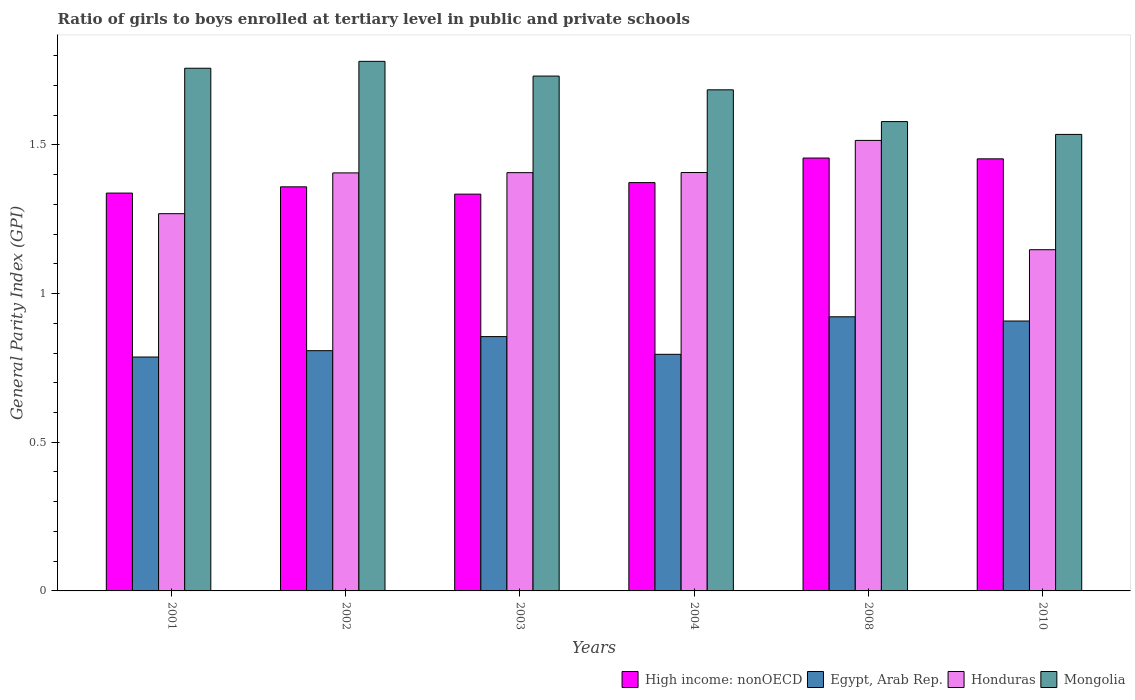How many bars are there on the 4th tick from the left?
Offer a very short reply. 4. What is the label of the 1st group of bars from the left?
Provide a short and direct response. 2001. In how many cases, is the number of bars for a given year not equal to the number of legend labels?
Make the answer very short. 0. What is the general parity index in Egypt, Arab Rep. in 2003?
Make the answer very short. 0.86. Across all years, what is the maximum general parity index in High income: nonOECD?
Offer a terse response. 1.46. Across all years, what is the minimum general parity index in Honduras?
Your response must be concise. 1.15. In which year was the general parity index in Honduras maximum?
Make the answer very short. 2008. What is the total general parity index in Mongolia in the graph?
Offer a very short reply. 10.07. What is the difference between the general parity index in Mongolia in 2001 and that in 2003?
Provide a succinct answer. 0.03. What is the difference between the general parity index in Egypt, Arab Rep. in 2002 and the general parity index in High income: nonOECD in 2004?
Offer a terse response. -0.57. What is the average general parity index in Egypt, Arab Rep. per year?
Your answer should be compact. 0.85. In the year 2008, what is the difference between the general parity index in High income: nonOECD and general parity index in Honduras?
Make the answer very short. -0.06. What is the ratio of the general parity index in Mongolia in 2002 to that in 2004?
Keep it short and to the point. 1.06. Is the general parity index in Egypt, Arab Rep. in 2002 less than that in 2003?
Ensure brevity in your answer.  Yes. What is the difference between the highest and the second highest general parity index in Mongolia?
Make the answer very short. 0.02. What is the difference between the highest and the lowest general parity index in High income: nonOECD?
Your response must be concise. 0.12. In how many years, is the general parity index in Mongolia greater than the average general parity index in Mongolia taken over all years?
Your answer should be very brief. 4. What does the 1st bar from the left in 2001 represents?
Your answer should be very brief. High income: nonOECD. What does the 3rd bar from the right in 2002 represents?
Your answer should be compact. Egypt, Arab Rep. What is the difference between two consecutive major ticks on the Y-axis?
Your answer should be compact. 0.5. Does the graph contain grids?
Your answer should be compact. No. Where does the legend appear in the graph?
Your answer should be very brief. Bottom right. How many legend labels are there?
Provide a succinct answer. 4. How are the legend labels stacked?
Your answer should be compact. Horizontal. What is the title of the graph?
Make the answer very short. Ratio of girls to boys enrolled at tertiary level in public and private schools. What is the label or title of the X-axis?
Ensure brevity in your answer.  Years. What is the label or title of the Y-axis?
Keep it short and to the point. General Parity Index (GPI). What is the General Parity Index (GPI) in High income: nonOECD in 2001?
Make the answer very short. 1.34. What is the General Parity Index (GPI) of Egypt, Arab Rep. in 2001?
Offer a very short reply. 0.79. What is the General Parity Index (GPI) in Honduras in 2001?
Offer a very short reply. 1.27. What is the General Parity Index (GPI) of Mongolia in 2001?
Make the answer very short. 1.76. What is the General Parity Index (GPI) in High income: nonOECD in 2002?
Offer a very short reply. 1.36. What is the General Parity Index (GPI) of Egypt, Arab Rep. in 2002?
Offer a very short reply. 0.81. What is the General Parity Index (GPI) in Honduras in 2002?
Your response must be concise. 1.41. What is the General Parity Index (GPI) of Mongolia in 2002?
Keep it short and to the point. 1.78. What is the General Parity Index (GPI) of High income: nonOECD in 2003?
Provide a short and direct response. 1.33. What is the General Parity Index (GPI) of Egypt, Arab Rep. in 2003?
Your answer should be compact. 0.86. What is the General Parity Index (GPI) of Honduras in 2003?
Offer a terse response. 1.41. What is the General Parity Index (GPI) in Mongolia in 2003?
Keep it short and to the point. 1.73. What is the General Parity Index (GPI) of High income: nonOECD in 2004?
Provide a succinct answer. 1.37. What is the General Parity Index (GPI) of Egypt, Arab Rep. in 2004?
Your answer should be very brief. 0.8. What is the General Parity Index (GPI) of Honduras in 2004?
Give a very brief answer. 1.41. What is the General Parity Index (GPI) in Mongolia in 2004?
Make the answer very short. 1.69. What is the General Parity Index (GPI) in High income: nonOECD in 2008?
Your answer should be compact. 1.46. What is the General Parity Index (GPI) of Egypt, Arab Rep. in 2008?
Your answer should be very brief. 0.92. What is the General Parity Index (GPI) of Honduras in 2008?
Your response must be concise. 1.51. What is the General Parity Index (GPI) of Mongolia in 2008?
Give a very brief answer. 1.58. What is the General Parity Index (GPI) in High income: nonOECD in 2010?
Give a very brief answer. 1.45. What is the General Parity Index (GPI) of Egypt, Arab Rep. in 2010?
Keep it short and to the point. 0.91. What is the General Parity Index (GPI) of Honduras in 2010?
Provide a short and direct response. 1.15. What is the General Parity Index (GPI) of Mongolia in 2010?
Keep it short and to the point. 1.54. Across all years, what is the maximum General Parity Index (GPI) in High income: nonOECD?
Your response must be concise. 1.46. Across all years, what is the maximum General Parity Index (GPI) of Egypt, Arab Rep.?
Make the answer very short. 0.92. Across all years, what is the maximum General Parity Index (GPI) of Honduras?
Make the answer very short. 1.51. Across all years, what is the maximum General Parity Index (GPI) of Mongolia?
Make the answer very short. 1.78. Across all years, what is the minimum General Parity Index (GPI) in High income: nonOECD?
Provide a short and direct response. 1.33. Across all years, what is the minimum General Parity Index (GPI) in Egypt, Arab Rep.?
Ensure brevity in your answer.  0.79. Across all years, what is the minimum General Parity Index (GPI) of Honduras?
Offer a terse response. 1.15. Across all years, what is the minimum General Parity Index (GPI) in Mongolia?
Keep it short and to the point. 1.54. What is the total General Parity Index (GPI) of High income: nonOECD in the graph?
Your response must be concise. 8.31. What is the total General Parity Index (GPI) of Egypt, Arab Rep. in the graph?
Provide a short and direct response. 5.07. What is the total General Parity Index (GPI) of Honduras in the graph?
Offer a terse response. 8.15. What is the total General Parity Index (GPI) in Mongolia in the graph?
Ensure brevity in your answer.  10.07. What is the difference between the General Parity Index (GPI) in High income: nonOECD in 2001 and that in 2002?
Give a very brief answer. -0.02. What is the difference between the General Parity Index (GPI) in Egypt, Arab Rep. in 2001 and that in 2002?
Your answer should be compact. -0.02. What is the difference between the General Parity Index (GPI) in Honduras in 2001 and that in 2002?
Ensure brevity in your answer.  -0.14. What is the difference between the General Parity Index (GPI) of Mongolia in 2001 and that in 2002?
Make the answer very short. -0.02. What is the difference between the General Parity Index (GPI) of High income: nonOECD in 2001 and that in 2003?
Your answer should be very brief. 0. What is the difference between the General Parity Index (GPI) in Egypt, Arab Rep. in 2001 and that in 2003?
Offer a terse response. -0.07. What is the difference between the General Parity Index (GPI) of Honduras in 2001 and that in 2003?
Offer a very short reply. -0.14. What is the difference between the General Parity Index (GPI) of Mongolia in 2001 and that in 2003?
Keep it short and to the point. 0.03. What is the difference between the General Parity Index (GPI) of High income: nonOECD in 2001 and that in 2004?
Offer a very short reply. -0.04. What is the difference between the General Parity Index (GPI) of Egypt, Arab Rep. in 2001 and that in 2004?
Your response must be concise. -0.01. What is the difference between the General Parity Index (GPI) in Honduras in 2001 and that in 2004?
Offer a very short reply. -0.14. What is the difference between the General Parity Index (GPI) in Mongolia in 2001 and that in 2004?
Ensure brevity in your answer.  0.07. What is the difference between the General Parity Index (GPI) of High income: nonOECD in 2001 and that in 2008?
Your answer should be compact. -0.12. What is the difference between the General Parity Index (GPI) of Egypt, Arab Rep. in 2001 and that in 2008?
Ensure brevity in your answer.  -0.14. What is the difference between the General Parity Index (GPI) of Honduras in 2001 and that in 2008?
Offer a very short reply. -0.25. What is the difference between the General Parity Index (GPI) of Mongolia in 2001 and that in 2008?
Give a very brief answer. 0.18. What is the difference between the General Parity Index (GPI) in High income: nonOECD in 2001 and that in 2010?
Provide a succinct answer. -0.12. What is the difference between the General Parity Index (GPI) of Egypt, Arab Rep. in 2001 and that in 2010?
Ensure brevity in your answer.  -0.12. What is the difference between the General Parity Index (GPI) in Honduras in 2001 and that in 2010?
Your answer should be compact. 0.12. What is the difference between the General Parity Index (GPI) of Mongolia in 2001 and that in 2010?
Make the answer very short. 0.22. What is the difference between the General Parity Index (GPI) of High income: nonOECD in 2002 and that in 2003?
Give a very brief answer. 0.02. What is the difference between the General Parity Index (GPI) of Egypt, Arab Rep. in 2002 and that in 2003?
Ensure brevity in your answer.  -0.05. What is the difference between the General Parity Index (GPI) in Honduras in 2002 and that in 2003?
Ensure brevity in your answer.  -0. What is the difference between the General Parity Index (GPI) of Mongolia in 2002 and that in 2003?
Ensure brevity in your answer.  0.05. What is the difference between the General Parity Index (GPI) of High income: nonOECD in 2002 and that in 2004?
Your response must be concise. -0.01. What is the difference between the General Parity Index (GPI) in Egypt, Arab Rep. in 2002 and that in 2004?
Give a very brief answer. 0.01. What is the difference between the General Parity Index (GPI) of Honduras in 2002 and that in 2004?
Give a very brief answer. -0. What is the difference between the General Parity Index (GPI) in Mongolia in 2002 and that in 2004?
Make the answer very short. 0.1. What is the difference between the General Parity Index (GPI) in High income: nonOECD in 2002 and that in 2008?
Make the answer very short. -0.1. What is the difference between the General Parity Index (GPI) in Egypt, Arab Rep. in 2002 and that in 2008?
Keep it short and to the point. -0.11. What is the difference between the General Parity Index (GPI) in Honduras in 2002 and that in 2008?
Keep it short and to the point. -0.11. What is the difference between the General Parity Index (GPI) in Mongolia in 2002 and that in 2008?
Your answer should be very brief. 0.2. What is the difference between the General Parity Index (GPI) in High income: nonOECD in 2002 and that in 2010?
Your answer should be very brief. -0.09. What is the difference between the General Parity Index (GPI) of Egypt, Arab Rep. in 2002 and that in 2010?
Your answer should be very brief. -0.1. What is the difference between the General Parity Index (GPI) in Honduras in 2002 and that in 2010?
Make the answer very short. 0.26. What is the difference between the General Parity Index (GPI) in Mongolia in 2002 and that in 2010?
Your answer should be very brief. 0.25. What is the difference between the General Parity Index (GPI) of High income: nonOECD in 2003 and that in 2004?
Make the answer very short. -0.04. What is the difference between the General Parity Index (GPI) in Egypt, Arab Rep. in 2003 and that in 2004?
Keep it short and to the point. 0.06. What is the difference between the General Parity Index (GPI) in Honduras in 2003 and that in 2004?
Offer a very short reply. -0. What is the difference between the General Parity Index (GPI) in Mongolia in 2003 and that in 2004?
Offer a terse response. 0.05. What is the difference between the General Parity Index (GPI) in High income: nonOECD in 2003 and that in 2008?
Offer a very short reply. -0.12. What is the difference between the General Parity Index (GPI) in Egypt, Arab Rep. in 2003 and that in 2008?
Provide a short and direct response. -0.07. What is the difference between the General Parity Index (GPI) in Honduras in 2003 and that in 2008?
Your answer should be very brief. -0.11. What is the difference between the General Parity Index (GPI) in Mongolia in 2003 and that in 2008?
Your answer should be very brief. 0.15. What is the difference between the General Parity Index (GPI) of High income: nonOECD in 2003 and that in 2010?
Your answer should be compact. -0.12. What is the difference between the General Parity Index (GPI) in Egypt, Arab Rep. in 2003 and that in 2010?
Offer a terse response. -0.05. What is the difference between the General Parity Index (GPI) in Honduras in 2003 and that in 2010?
Your answer should be compact. 0.26. What is the difference between the General Parity Index (GPI) in Mongolia in 2003 and that in 2010?
Your answer should be compact. 0.2. What is the difference between the General Parity Index (GPI) in High income: nonOECD in 2004 and that in 2008?
Your response must be concise. -0.08. What is the difference between the General Parity Index (GPI) of Egypt, Arab Rep. in 2004 and that in 2008?
Offer a terse response. -0.13. What is the difference between the General Parity Index (GPI) in Honduras in 2004 and that in 2008?
Provide a short and direct response. -0.11. What is the difference between the General Parity Index (GPI) of Mongolia in 2004 and that in 2008?
Offer a very short reply. 0.11. What is the difference between the General Parity Index (GPI) in High income: nonOECD in 2004 and that in 2010?
Ensure brevity in your answer.  -0.08. What is the difference between the General Parity Index (GPI) in Egypt, Arab Rep. in 2004 and that in 2010?
Give a very brief answer. -0.11. What is the difference between the General Parity Index (GPI) of Honduras in 2004 and that in 2010?
Offer a very short reply. 0.26. What is the difference between the General Parity Index (GPI) in High income: nonOECD in 2008 and that in 2010?
Ensure brevity in your answer.  0. What is the difference between the General Parity Index (GPI) of Egypt, Arab Rep. in 2008 and that in 2010?
Ensure brevity in your answer.  0.01. What is the difference between the General Parity Index (GPI) of Honduras in 2008 and that in 2010?
Your answer should be very brief. 0.37. What is the difference between the General Parity Index (GPI) in Mongolia in 2008 and that in 2010?
Make the answer very short. 0.04. What is the difference between the General Parity Index (GPI) of High income: nonOECD in 2001 and the General Parity Index (GPI) of Egypt, Arab Rep. in 2002?
Your response must be concise. 0.53. What is the difference between the General Parity Index (GPI) in High income: nonOECD in 2001 and the General Parity Index (GPI) in Honduras in 2002?
Your answer should be very brief. -0.07. What is the difference between the General Parity Index (GPI) in High income: nonOECD in 2001 and the General Parity Index (GPI) in Mongolia in 2002?
Offer a very short reply. -0.44. What is the difference between the General Parity Index (GPI) in Egypt, Arab Rep. in 2001 and the General Parity Index (GPI) in Honduras in 2002?
Your answer should be compact. -0.62. What is the difference between the General Parity Index (GPI) of Egypt, Arab Rep. in 2001 and the General Parity Index (GPI) of Mongolia in 2002?
Offer a terse response. -0.99. What is the difference between the General Parity Index (GPI) in Honduras in 2001 and the General Parity Index (GPI) in Mongolia in 2002?
Ensure brevity in your answer.  -0.51. What is the difference between the General Parity Index (GPI) in High income: nonOECD in 2001 and the General Parity Index (GPI) in Egypt, Arab Rep. in 2003?
Your answer should be compact. 0.48. What is the difference between the General Parity Index (GPI) of High income: nonOECD in 2001 and the General Parity Index (GPI) of Honduras in 2003?
Offer a very short reply. -0.07. What is the difference between the General Parity Index (GPI) in High income: nonOECD in 2001 and the General Parity Index (GPI) in Mongolia in 2003?
Your answer should be very brief. -0.39. What is the difference between the General Parity Index (GPI) in Egypt, Arab Rep. in 2001 and the General Parity Index (GPI) in Honduras in 2003?
Offer a very short reply. -0.62. What is the difference between the General Parity Index (GPI) in Egypt, Arab Rep. in 2001 and the General Parity Index (GPI) in Mongolia in 2003?
Provide a short and direct response. -0.94. What is the difference between the General Parity Index (GPI) in Honduras in 2001 and the General Parity Index (GPI) in Mongolia in 2003?
Your response must be concise. -0.46. What is the difference between the General Parity Index (GPI) of High income: nonOECD in 2001 and the General Parity Index (GPI) of Egypt, Arab Rep. in 2004?
Your answer should be compact. 0.54. What is the difference between the General Parity Index (GPI) of High income: nonOECD in 2001 and the General Parity Index (GPI) of Honduras in 2004?
Make the answer very short. -0.07. What is the difference between the General Parity Index (GPI) of High income: nonOECD in 2001 and the General Parity Index (GPI) of Mongolia in 2004?
Your answer should be compact. -0.35. What is the difference between the General Parity Index (GPI) in Egypt, Arab Rep. in 2001 and the General Parity Index (GPI) in Honduras in 2004?
Your answer should be very brief. -0.62. What is the difference between the General Parity Index (GPI) in Egypt, Arab Rep. in 2001 and the General Parity Index (GPI) in Mongolia in 2004?
Keep it short and to the point. -0.9. What is the difference between the General Parity Index (GPI) of Honduras in 2001 and the General Parity Index (GPI) of Mongolia in 2004?
Provide a succinct answer. -0.42. What is the difference between the General Parity Index (GPI) of High income: nonOECD in 2001 and the General Parity Index (GPI) of Egypt, Arab Rep. in 2008?
Keep it short and to the point. 0.42. What is the difference between the General Parity Index (GPI) in High income: nonOECD in 2001 and the General Parity Index (GPI) in Honduras in 2008?
Ensure brevity in your answer.  -0.18. What is the difference between the General Parity Index (GPI) of High income: nonOECD in 2001 and the General Parity Index (GPI) of Mongolia in 2008?
Offer a terse response. -0.24. What is the difference between the General Parity Index (GPI) in Egypt, Arab Rep. in 2001 and the General Parity Index (GPI) in Honduras in 2008?
Keep it short and to the point. -0.73. What is the difference between the General Parity Index (GPI) of Egypt, Arab Rep. in 2001 and the General Parity Index (GPI) of Mongolia in 2008?
Your response must be concise. -0.79. What is the difference between the General Parity Index (GPI) of Honduras in 2001 and the General Parity Index (GPI) of Mongolia in 2008?
Offer a terse response. -0.31. What is the difference between the General Parity Index (GPI) in High income: nonOECD in 2001 and the General Parity Index (GPI) in Egypt, Arab Rep. in 2010?
Provide a succinct answer. 0.43. What is the difference between the General Parity Index (GPI) in High income: nonOECD in 2001 and the General Parity Index (GPI) in Honduras in 2010?
Give a very brief answer. 0.19. What is the difference between the General Parity Index (GPI) in High income: nonOECD in 2001 and the General Parity Index (GPI) in Mongolia in 2010?
Ensure brevity in your answer.  -0.2. What is the difference between the General Parity Index (GPI) in Egypt, Arab Rep. in 2001 and the General Parity Index (GPI) in Honduras in 2010?
Provide a short and direct response. -0.36. What is the difference between the General Parity Index (GPI) of Egypt, Arab Rep. in 2001 and the General Parity Index (GPI) of Mongolia in 2010?
Your answer should be compact. -0.75. What is the difference between the General Parity Index (GPI) of Honduras in 2001 and the General Parity Index (GPI) of Mongolia in 2010?
Provide a short and direct response. -0.27. What is the difference between the General Parity Index (GPI) in High income: nonOECD in 2002 and the General Parity Index (GPI) in Egypt, Arab Rep. in 2003?
Keep it short and to the point. 0.5. What is the difference between the General Parity Index (GPI) in High income: nonOECD in 2002 and the General Parity Index (GPI) in Honduras in 2003?
Provide a succinct answer. -0.05. What is the difference between the General Parity Index (GPI) of High income: nonOECD in 2002 and the General Parity Index (GPI) of Mongolia in 2003?
Provide a succinct answer. -0.37. What is the difference between the General Parity Index (GPI) of Egypt, Arab Rep. in 2002 and the General Parity Index (GPI) of Honduras in 2003?
Your response must be concise. -0.6. What is the difference between the General Parity Index (GPI) in Egypt, Arab Rep. in 2002 and the General Parity Index (GPI) in Mongolia in 2003?
Your response must be concise. -0.92. What is the difference between the General Parity Index (GPI) of Honduras in 2002 and the General Parity Index (GPI) of Mongolia in 2003?
Keep it short and to the point. -0.33. What is the difference between the General Parity Index (GPI) in High income: nonOECD in 2002 and the General Parity Index (GPI) in Egypt, Arab Rep. in 2004?
Ensure brevity in your answer.  0.56. What is the difference between the General Parity Index (GPI) in High income: nonOECD in 2002 and the General Parity Index (GPI) in Honduras in 2004?
Give a very brief answer. -0.05. What is the difference between the General Parity Index (GPI) of High income: nonOECD in 2002 and the General Parity Index (GPI) of Mongolia in 2004?
Give a very brief answer. -0.33. What is the difference between the General Parity Index (GPI) of Egypt, Arab Rep. in 2002 and the General Parity Index (GPI) of Honduras in 2004?
Your response must be concise. -0.6. What is the difference between the General Parity Index (GPI) of Egypt, Arab Rep. in 2002 and the General Parity Index (GPI) of Mongolia in 2004?
Offer a very short reply. -0.88. What is the difference between the General Parity Index (GPI) in Honduras in 2002 and the General Parity Index (GPI) in Mongolia in 2004?
Make the answer very short. -0.28. What is the difference between the General Parity Index (GPI) in High income: nonOECD in 2002 and the General Parity Index (GPI) in Egypt, Arab Rep. in 2008?
Make the answer very short. 0.44. What is the difference between the General Parity Index (GPI) of High income: nonOECD in 2002 and the General Parity Index (GPI) of Honduras in 2008?
Keep it short and to the point. -0.16. What is the difference between the General Parity Index (GPI) of High income: nonOECD in 2002 and the General Parity Index (GPI) of Mongolia in 2008?
Offer a very short reply. -0.22. What is the difference between the General Parity Index (GPI) of Egypt, Arab Rep. in 2002 and the General Parity Index (GPI) of Honduras in 2008?
Provide a short and direct response. -0.71. What is the difference between the General Parity Index (GPI) of Egypt, Arab Rep. in 2002 and the General Parity Index (GPI) of Mongolia in 2008?
Make the answer very short. -0.77. What is the difference between the General Parity Index (GPI) of Honduras in 2002 and the General Parity Index (GPI) of Mongolia in 2008?
Give a very brief answer. -0.17. What is the difference between the General Parity Index (GPI) of High income: nonOECD in 2002 and the General Parity Index (GPI) of Egypt, Arab Rep. in 2010?
Provide a short and direct response. 0.45. What is the difference between the General Parity Index (GPI) in High income: nonOECD in 2002 and the General Parity Index (GPI) in Honduras in 2010?
Offer a very short reply. 0.21. What is the difference between the General Parity Index (GPI) of High income: nonOECD in 2002 and the General Parity Index (GPI) of Mongolia in 2010?
Provide a short and direct response. -0.18. What is the difference between the General Parity Index (GPI) in Egypt, Arab Rep. in 2002 and the General Parity Index (GPI) in Honduras in 2010?
Your answer should be compact. -0.34. What is the difference between the General Parity Index (GPI) in Egypt, Arab Rep. in 2002 and the General Parity Index (GPI) in Mongolia in 2010?
Your answer should be compact. -0.73. What is the difference between the General Parity Index (GPI) in Honduras in 2002 and the General Parity Index (GPI) in Mongolia in 2010?
Provide a succinct answer. -0.13. What is the difference between the General Parity Index (GPI) in High income: nonOECD in 2003 and the General Parity Index (GPI) in Egypt, Arab Rep. in 2004?
Ensure brevity in your answer.  0.54. What is the difference between the General Parity Index (GPI) in High income: nonOECD in 2003 and the General Parity Index (GPI) in Honduras in 2004?
Your answer should be compact. -0.07. What is the difference between the General Parity Index (GPI) in High income: nonOECD in 2003 and the General Parity Index (GPI) in Mongolia in 2004?
Keep it short and to the point. -0.35. What is the difference between the General Parity Index (GPI) in Egypt, Arab Rep. in 2003 and the General Parity Index (GPI) in Honduras in 2004?
Your answer should be compact. -0.55. What is the difference between the General Parity Index (GPI) of Egypt, Arab Rep. in 2003 and the General Parity Index (GPI) of Mongolia in 2004?
Your response must be concise. -0.83. What is the difference between the General Parity Index (GPI) in Honduras in 2003 and the General Parity Index (GPI) in Mongolia in 2004?
Offer a terse response. -0.28. What is the difference between the General Parity Index (GPI) in High income: nonOECD in 2003 and the General Parity Index (GPI) in Egypt, Arab Rep. in 2008?
Your response must be concise. 0.41. What is the difference between the General Parity Index (GPI) in High income: nonOECD in 2003 and the General Parity Index (GPI) in Honduras in 2008?
Your answer should be very brief. -0.18. What is the difference between the General Parity Index (GPI) in High income: nonOECD in 2003 and the General Parity Index (GPI) in Mongolia in 2008?
Make the answer very short. -0.24. What is the difference between the General Parity Index (GPI) of Egypt, Arab Rep. in 2003 and the General Parity Index (GPI) of Honduras in 2008?
Keep it short and to the point. -0.66. What is the difference between the General Parity Index (GPI) of Egypt, Arab Rep. in 2003 and the General Parity Index (GPI) of Mongolia in 2008?
Your answer should be compact. -0.72. What is the difference between the General Parity Index (GPI) in Honduras in 2003 and the General Parity Index (GPI) in Mongolia in 2008?
Your answer should be compact. -0.17. What is the difference between the General Parity Index (GPI) of High income: nonOECD in 2003 and the General Parity Index (GPI) of Egypt, Arab Rep. in 2010?
Your answer should be very brief. 0.43. What is the difference between the General Parity Index (GPI) of High income: nonOECD in 2003 and the General Parity Index (GPI) of Honduras in 2010?
Make the answer very short. 0.19. What is the difference between the General Parity Index (GPI) of High income: nonOECD in 2003 and the General Parity Index (GPI) of Mongolia in 2010?
Make the answer very short. -0.2. What is the difference between the General Parity Index (GPI) of Egypt, Arab Rep. in 2003 and the General Parity Index (GPI) of Honduras in 2010?
Provide a succinct answer. -0.29. What is the difference between the General Parity Index (GPI) in Egypt, Arab Rep. in 2003 and the General Parity Index (GPI) in Mongolia in 2010?
Keep it short and to the point. -0.68. What is the difference between the General Parity Index (GPI) of Honduras in 2003 and the General Parity Index (GPI) of Mongolia in 2010?
Ensure brevity in your answer.  -0.13. What is the difference between the General Parity Index (GPI) in High income: nonOECD in 2004 and the General Parity Index (GPI) in Egypt, Arab Rep. in 2008?
Provide a short and direct response. 0.45. What is the difference between the General Parity Index (GPI) in High income: nonOECD in 2004 and the General Parity Index (GPI) in Honduras in 2008?
Ensure brevity in your answer.  -0.14. What is the difference between the General Parity Index (GPI) in High income: nonOECD in 2004 and the General Parity Index (GPI) in Mongolia in 2008?
Make the answer very short. -0.21. What is the difference between the General Parity Index (GPI) of Egypt, Arab Rep. in 2004 and the General Parity Index (GPI) of Honduras in 2008?
Give a very brief answer. -0.72. What is the difference between the General Parity Index (GPI) in Egypt, Arab Rep. in 2004 and the General Parity Index (GPI) in Mongolia in 2008?
Your response must be concise. -0.78. What is the difference between the General Parity Index (GPI) of Honduras in 2004 and the General Parity Index (GPI) of Mongolia in 2008?
Your answer should be compact. -0.17. What is the difference between the General Parity Index (GPI) of High income: nonOECD in 2004 and the General Parity Index (GPI) of Egypt, Arab Rep. in 2010?
Offer a very short reply. 0.47. What is the difference between the General Parity Index (GPI) of High income: nonOECD in 2004 and the General Parity Index (GPI) of Honduras in 2010?
Provide a succinct answer. 0.23. What is the difference between the General Parity Index (GPI) in High income: nonOECD in 2004 and the General Parity Index (GPI) in Mongolia in 2010?
Your answer should be very brief. -0.16. What is the difference between the General Parity Index (GPI) of Egypt, Arab Rep. in 2004 and the General Parity Index (GPI) of Honduras in 2010?
Ensure brevity in your answer.  -0.35. What is the difference between the General Parity Index (GPI) in Egypt, Arab Rep. in 2004 and the General Parity Index (GPI) in Mongolia in 2010?
Offer a very short reply. -0.74. What is the difference between the General Parity Index (GPI) in Honduras in 2004 and the General Parity Index (GPI) in Mongolia in 2010?
Provide a succinct answer. -0.13. What is the difference between the General Parity Index (GPI) of High income: nonOECD in 2008 and the General Parity Index (GPI) of Egypt, Arab Rep. in 2010?
Ensure brevity in your answer.  0.55. What is the difference between the General Parity Index (GPI) in High income: nonOECD in 2008 and the General Parity Index (GPI) in Honduras in 2010?
Keep it short and to the point. 0.31. What is the difference between the General Parity Index (GPI) of High income: nonOECD in 2008 and the General Parity Index (GPI) of Mongolia in 2010?
Your answer should be compact. -0.08. What is the difference between the General Parity Index (GPI) of Egypt, Arab Rep. in 2008 and the General Parity Index (GPI) of Honduras in 2010?
Give a very brief answer. -0.23. What is the difference between the General Parity Index (GPI) of Egypt, Arab Rep. in 2008 and the General Parity Index (GPI) of Mongolia in 2010?
Offer a very short reply. -0.61. What is the difference between the General Parity Index (GPI) of Honduras in 2008 and the General Parity Index (GPI) of Mongolia in 2010?
Provide a succinct answer. -0.02. What is the average General Parity Index (GPI) in High income: nonOECD per year?
Your answer should be compact. 1.39. What is the average General Parity Index (GPI) of Egypt, Arab Rep. per year?
Ensure brevity in your answer.  0.85. What is the average General Parity Index (GPI) of Honduras per year?
Make the answer very short. 1.36. What is the average General Parity Index (GPI) in Mongolia per year?
Provide a succinct answer. 1.68. In the year 2001, what is the difference between the General Parity Index (GPI) of High income: nonOECD and General Parity Index (GPI) of Egypt, Arab Rep.?
Your answer should be very brief. 0.55. In the year 2001, what is the difference between the General Parity Index (GPI) in High income: nonOECD and General Parity Index (GPI) in Honduras?
Make the answer very short. 0.07. In the year 2001, what is the difference between the General Parity Index (GPI) of High income: nonOECD and General Parity Index (GPI) of Mongolia?
Provide a succinct answer. -0.42. In the year 2001, what is the difference between the General Parity Index (GPI) of Egypt, Arab Rep. and General Parity Index (GPI) of Honduras?
Provide a short and direct response. -0.48. In the year 2001, what is the difference between the General Parity Index (GPI) in Egypt, Arab Rep. and General Parity Index (GPI) in Mongolia?
Your answer should be compact. -0.97. In the year 2001, what is the difference between the General Parity Index (GPI) in Honduras and General Parity Index (GPI) in Mongolia?
Ensure brevity in your answer.  -0.49. In the year 2002, what is the difference between the General Parity Index (GPI) of High income: nonOECD and General Parity Index (GPI) of Egypt, Arab Rep.?
Make the answer very short. 0.55. In the year 2002, what is the difference between the General Parity Index (GPI) of High income: nonOECD and General Parity Index (GPI) of Honduras?
Offer a terse response. -0.05. In the year 2002, what is the difference between the General Parity Index (GPI) in High income: nonOECD and General Parity Index (GPI) in Mongolia?
Give a very brief answer. -0.42. In the year 2002, what is the difference between the General Parity Index (GPI) of Egypt, Arab Rep. and General Parity Index (GPI) of Honduras?
Your answer should be compact. -0.6. In the year 2002, what is the difference between the General Parity Index (GPI) in Egypt, Arab Rep. and General Parity Index (GPI) in Mongolia?
Your answer should be very brief. -0.97. In the year 2002, what is the difference between the General Parity Index (GPI) of Honduras and General Parity Index (GPI) of Mongolia?
Your answer should be compact. -0.38. In the year 2003, what is the difference between the General Parity Index (GPI) in High income: nonOECD and General Parity Index (GPI) in Egypt, Arab Rep.?
Your answer should be compact. 0.48. In the year 2003, what is the difference between the General Parity Index (GPI) of High income: nonOECD and General Parity Index (GPI) of Honduras?
Make the answer very short. -0.07. In the year 2003, what is the difference between the General Parity Index (GPI) of High income: nonOECD and General Parity Index (GPI) of Mongolia?
Make the answer very short. -0.4. In the year 2003, what is the difference between the General Parity Index (GPI) in Egypt, Arab Rep. and General Parity Index (GPI) in Honduras?
Provide a short and direct response. -0.55. In the year 2003, what is the difference between the General Parity Index (GPI) of Egypt, Arab Rep. and General Parity Index (GPI) of Mongolia?
Ensure brevity in your answer.  -0.88. In the year 2003, what is the difference between the General Parity Index (GPI) of Honduras and General Parity Index (GPI) of Mongolia?
Keep it short and to the point. -0.32. In the year 2004, what is the difference between the General Parity Index (GPI) of High income: nonOECD and General Parity Index (GPI) of Egypt, Arab Rep.?
Offer a terse response. 0.58. In the year 2004, what is the difference between the General Parity Index (GPI) in High income: nonOECD and General Parity Index (GPI) in Honduras?
Make the answer very short. -0.03. In the year 2004, what is the difference between the General Parity Index (GPI) of High income: nonOECD and General Parity Index (GPI) of Mongolia?
Give a very brief answer. -0.31. In the year 2004, what is the difference between the General Parity Index (GPI) in Egypt, Arab Rep. and General Parity Index (GPI) in Honduras?
Your answer should be compact. -0.61. In the year 2004, what is the difference between the General Parity Index (GPI) in Egypt, Arab Rep. and General Parity Index (GPI) in Mongolia?
Your answer should be compact. -0.89. In the year 2004, what is the difference between the General Parity Index (GPI) in Honduras and General Parity Index (GPI) in Mongolia?
Keep it short and to the point. -0.28. In the year 2008, what is the difference between the General Parity Index (GPI) of High income: nonOECD and General Parity Index (GPI) of Egypt, Arab Rep.?
Your answer should be very brief. 0.53. In the year 2008, what is the difference between the General Parity Index (GPI) in High income: nonOECD and General Parity Index (GPI) in Honduras?
Make the answer very short. -0.06. In the year 2008, what is the difference between the General Parity Index (GPI) of High income: nonOECD and General Parity Index (GPI) of Mongolia?
Provide a succinct answer. -0.12. In the year 2008, what is the difference between the General Parity Index (GPI) of Egypt, Arab Rep. and General Parity Index (GPI) of Honduras?
Your response must be concise. -0.59. In the year 2008, what is the difference between the General Parity Index (GPI) in Egypt, Arab Rep. and General Parity Index (GPI) in Mongolia?
Make the answer very short. -0.66. In the year 2008, what is the difference between the General Parity Index (GPI) in Honduras and General Parity Index (GPI) in Mongolia?
Give a very brief answer. -0.06. In the year 2010, what is the difference between the General Parity Index (GPI) in High income: nonOECD and General Parity Index (GPI) in Egypt, Arab Rep.?
Your answer should be very brief. 0.55. In the year 2010, what is the difference between the General Parity Index (GPI) in High income: nonOECD and General Parity Index (GPI) in Honduras?
Keep it short and to the point. 0.31. In the year 2010, what is the difference between the General Parity Index (GPI) of High income: nonOECD and General Parity Index (GPI) of Mongolia?
Provide a short and direct response. -0.08. In the year 2010, what is the difference between the General Parity Index (GPI) of Egypt, Arab Rep. and General Parity Index (GPI) of Honduras?
Your answer should be compact. -0.24. In the year 2010, what is the difference between the General Parity Index (GPI) of Egypt, Arab Rep. and General Parity Index (GPI) of Mongolia?
Make the answer very short. -0.63. In the year 2010, what is the difference between the General Parity Index (GPI) in Honduras and General Parity Index (GPI) in Mongolia?
Your answer should be compact. -0.39. What is the ratio of the General Parity Index (GPI) in High income: nonOECD in 2001 to that in 2002?
Provide a short and direct response. 0.98. What is the ratio of the General Parity Index (GPI) in Egypt, Arab Rep. in 2001 to that in 2002?
Ensure brevity in your answer.  0.97. What is the ratio of the General Parity Index (GPI) in Honduras in 2001 to that in 2002?
Make the answer very short. 0.9. What is the ratio of the General Parity Index (GPI) of Mongolia in 2001 to that in 2002?
Your answer should be compact. 0.99. What is the ratio of the General Parity Index (GPI) in High income: nonOECD in 2001 to that in 2003?
Your response must be concise. 1. What is the ratio of the General Parity Index (GPI) of Egypt, Arab Rep. in 2001 to that in 2003?
Ensure brevity in your answer.  0.92. What is the ratio of the General Parity Index (GPI) in Honduras in 2001 to that in 2003?
Your answer should be very brief. 0.9. What is the ratio of the General Parity Index (GPI) of Mongolia in 2001 to that in 2003?
Your answer should be compact. 1.02. What is the ratio of the General Parity Index (GPI) in High income: nonOECD in 2001 to that in 2004?
Your response must be concise. 0.97. What is the ratio of the General Parity Index (GPI) of Honduras in 2001 to that in 2004?
Offer a very short reply. 0.9. What is the ratio of the General Parity Index (GPI) of Mongolia in 2001 to that in 2004?
Provide a short and direct response. 1.04. What is the ratio of the General Parity Index (GPI) of High income: nonOECD in 2001 to that in 2008?
Your answer should be compact. 0.92. What is the ratio of the General Parity Index (GPI) in Egypt, Arab Rep. in 2001 to that in 2008?
Ensure brevity in your answer.  0.85. What is the ratio of the General Parity Index (GPI) in Honduras in 2001 to that in 2008?
Ensure brevity in your answer.  0.84. What is the ratio of the General Parity Index (GPI) in Mongolia in 2001 to that in 2008?
Your answer should be very brief. 1.11. What is the ratio of the General Parity Index (GPI) of High income: nonOECD in 2001 to that in 2010?
Your response must be concise. 0.92. What is the ratio of the General Parity Index (GPI) of Egypt, Arab Rep. in 2001 to that in 2010?
Keep it short and to the point. 0.87. What is the ratio of the General Parity Index (GPI) of Honduras in 2001 to that in 2010?
Your response must be concise. 1.11. What is the ratio of the General Parity Index (GPI) in Mongolia in 2001 to that in 2010?
Your answer should be very brief. 1.14. What is the ratio of the General Parity Index (GPI) in High income: nonOECD in 2002 to that in 2003?
Offer a terse response. 1.02. What is the ratio of the General Parity Index (GPI) in Egypt, Arab Rep. in 2002 to that in 2003?
Make the answer very short. 0.94. What is the ratio of the General Parity Index (GPI) in Honduras in 2002 to that in 2003?
Offer a terse response. 1. What is the ratio of the General Parity Index (GPI) of Mongolia in 2002 to that in 2003?
Your answer should be compact. 1.03. What is the ratio of the General Parity Index (GPI) of Egypt, Arab Rep. in 2002 to that in 2004?
Keep it short and to the point. 1.02. What is the ratio of the General Parity Index (GPI) of Mongolia in 2002 to that in 2004?
Your answer should be very brief. 1.06. What is the ratio of the General Parity Index (GPI) in High income: nonOECD in 2002 to that in 2008?
Ensure brevity in your answer.  0.93. What is the ratio of the General Parity Index (GPI) of Egypt, Arab Rep. in 2002 to that in 2008?
Your answer should be very brief. 0.88. What is the ratio of the General Parity Index (GPI) in Honduras in 2002 to that in 2008?
Provide a short and direct response. 0.93. What is the ratio of the General Parity Index (GPI) in Mongolia in 2002 to that in 2008?
Provide a short and direct response. 1.13. What is the ratio of the General Parity Index (GPI) in High income: nonOECD in 2002 to that in 2010?
Offer a very short reply. 0.94. What is the ratio of the General Parity Index (GPI) in Egypt, Arab Rep. in 2002 to that in 2010?
Keep it short and to the point. 0.89. What is the ratio of the General Parity Index (GPI) of Honduras in 2002 to that in 2010?
Your answer should be compact. 1.23. What is the ratio of the General Parity Index (GPI) in Mongolia in 2002 to that in 2010?
Your answer should be very brief. 1.16. What is the ratio of the General Parity Index (GPI) in High income: nonOECD in 2003 to that in 2004?
Your answer should be very brief. 0.97. What is the ratio of the General Parity Index (GPI) of Egypt, Arab Rep. in 2003 to that in 2004?
Your answer should be very brief. 1.07. What is the ratio of the General Parity Index (GPI) of Mongolia in 2003 to that in 2004?
Offer a very short reply. 1.03. What is the ratio of the General Parity Index (GPI) in High income: nonOECD in 2003 to that in 2008?
Offer a very short reply. 0.92. What is the ratio of the General Parity Index (GPI) of Egypt, Arab Rep. in 2003 to that in 2008?
Give a very brief answer. 0.93. What is the ratio of the General Parity Index (GPI) of Honduras in 2003 to that in 2008?
Your answer should be very brief. 0.93. What is the ratio of the General Parity Index (GPI) of Mongolia in 2003 to that in 2008?
Your answer should be compact. 1.1. What is the ratio of the General Parity Index (GPI) in High income: nonOECD in 2003 to that in 2010?
Your answer should be very brief. 0.92. What is the ratio of the General Parity Index (GPI) of Egypt, Arab Rep. in 2003 to that in 2010?
Your answer should be very brief. 0.94. What is the ratio of the General Parity Index (GPI) of Honduras in 2003 to that in 2010?
Provide a succinct answer. 1.23. What is the ratio of the General Parity Index (GPI) in Mongolia in 2003 to that in 2010?
Make the answer very short. 1.13. What is the ratio of the General Parity Index (GPI) in High income: nonOECD in 2004 to that in 2008?
Keep it short and to the point. 0.94. What is the ratio of the General Parity Index (GPI) in Egypt, Arab Rep. in 2004 to that in 2008?
Offer a terse response. 0.86. What is the ratio of the General Parity Index (GPI) of Honduras in 2004 to that in 2008?
Your answer should be very brief. 0.93. What is the ratio of the General Parity Index (GPI) in Mongolia in 2004 to that in 2008?
Offer a terse response. 1.07. What is the ratio of the General Parity Index (GPI) in High income: nonOECD in 2004 to that in 2010?
Your answer should be very brief. 0.94. What is the ratio of the General Parity Index (GPI) of Egypt, Arab Rep. in 2004 to that in 2010?
Provide a succinct answer. 0.88. What is the ratio of the General Parity Index (GPI) of Honduras in 2004 to that in 2010?
Give a very brief answer. 1.23. What is the ratio of the General Parity Index (GPI) in Mongolia in 2004 to that in 2010?
Give a very brief answer. 1.1. What is the ratio of the General Parity Index (GPI) of Egypt, Arab Rep. in 2008 to that in 2010?
Provide a succinct answer. 1.02. What is the ratio of the General Parity Index (GPI) in Honduras in 2008 to that in 2010?
Make the answer very short. 1.32. What is the ratio of the General Parity Index (GPI) of Mongolia in 2008 to that in 2010?
Provide a succinct answer. 1.03. What is the difference between the highest and the second highest General Parity Index (GPI) in High income: nonOECD?
Your answer should be very brief. 0. What is the difference between the highest and the second highest General Parity Index (GPI) in Egypt, Arab Rep.?
Provide a succinct answer. 0.01. What is the difference between the highest and the second highest General Parity Index (GPI) of Honduras?
Your answer should be very brief. 0.11. What is the difference between the highest and the second highest General Parity Index (GPI) in Mongolia?
Offer a terse response. 0.02. What is the difference between the highest and the lowest General Parity Index (GPI) of High income: nonOECD?
Make the answer very short. 0.12. What is the difference between the highest and the lowest General Parity Index (GPI) in Egypt, Arab Rep.?
Your answer should be compact. 0.14. What is the difference between the highest and the lowest General Parity Index (GPI) of Honduras?
Your response must be concise. 0.37. What is the difference between the highest and the lowest General Parity Index (GPI) in Mongolia?
Your response must be concise. 0.25. 